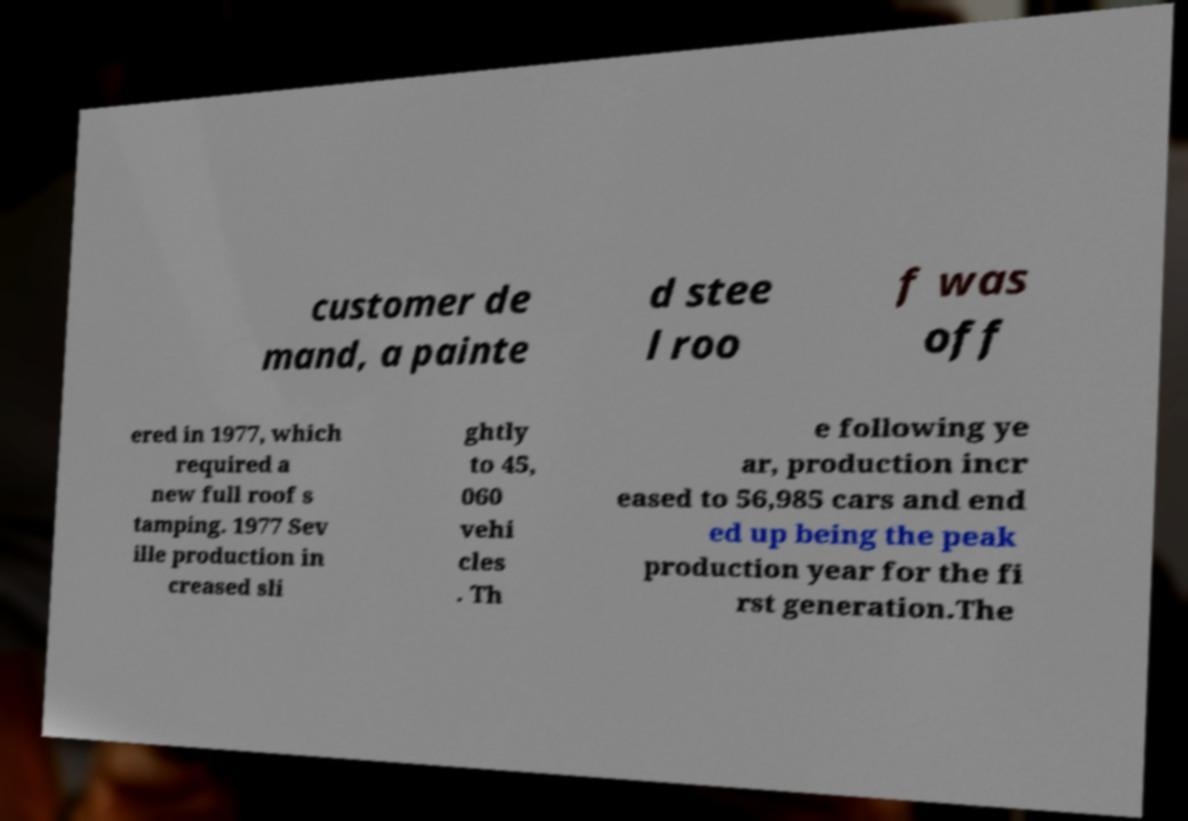Could you extract and type out the text from this image? customer de mand, a painte d stee l roo f was off ered in 1977, which required a new full roof s tamping. 1977 Sev ille production in creased sli ghtly to 45, 060 vehi cles . Th e following ye ar, production incr eased to 56,985 cars and end ed up being the peak production year for the fi rst generation.The 